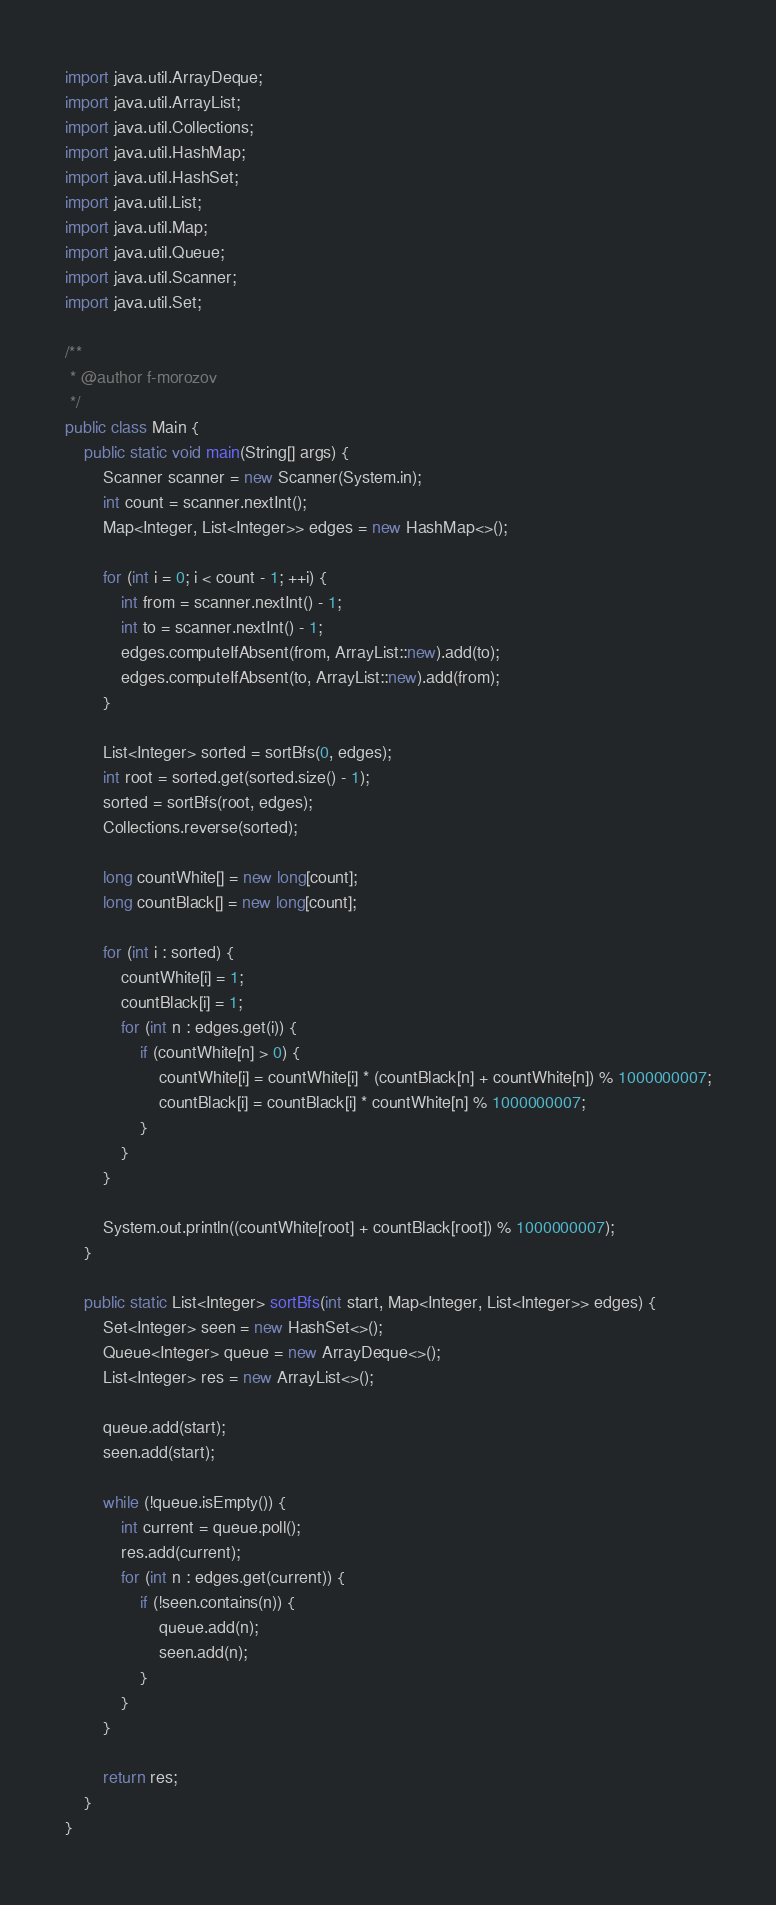<code> <loc_0><loc_0><loc_500><loc_500><_Java_>import java.util.ArrayDeque;
import java.util.ArrayList;
import java.util.Collections;
import java.util.HashMap;
import java.util.HashSet;
import java.util.List;
import java.util.Map;
import java.util.Queue;
import java.util.Scanner;
import java.util.Set;

/**
 * @author f-morozov
 */
public class Main {
    public static void main(String[] args) {
        Scanner scanner = new Scanner(System.in);
        int count = scanner.nextInt();
        Map<Integer, List<Integer>> edges = new HashMap<>();

        for (int i = 0; i < count - 1; ++i) {
            int from = scanner.nextInt() - 1;
            int to = scanner.nextInt() - 1;
            edges.computeIfAbsent(from, ArrayList::new).add(to);
            edges.computeIfAbsent(to, ArrayList::new).add(from);
        }

        List<Integer> sorted = sortBfs(0, edges);
        int root = sorted.get(sorted.size() - 1);
        sorted = sortBfs(root, edges);
        Collections.reverse(sorted);

        long countWhite[] = new long[count];
        long countBlack[] = new long[count];

        for (int i : sorted) {
            countWhite[i] = 1;
            countBlack[i] = 1;
            for (int n : edges.get(i)) {
                if (countWhite[n] > 0) {
                    countWhite[i] = countWhite[i] * (countBlack[n] + countWhite[n]) % 1000000007;
                    countBlack[i] = countBlack[i] * countWhite[n] % 1000000007;
                }
            }
        }

        System.out.println((countWhite[root] + countBlack[root]) % 1000000007);
    }

    public static List<Integer> sortBfs(int start, Map<Integer, List<Integer>> edges) {
        Set<Integer> seen = new HashSet<>();
        Queue<Integer> queue = new ArrayDeque<>();
        List<Integer> res = new ArrayList<>();

        queue.add(start);
        seen.add(start);

        while (!queue.isEmpty()) {
            int current = queue.poll();
            res.add(current);
            for (int n : edges.get(current)) {
                if (!seen.contains(n)) {
                    queue.add(n);
                    seen.add(n);
                }
            }
        }

        return res;
    }
}</code> 